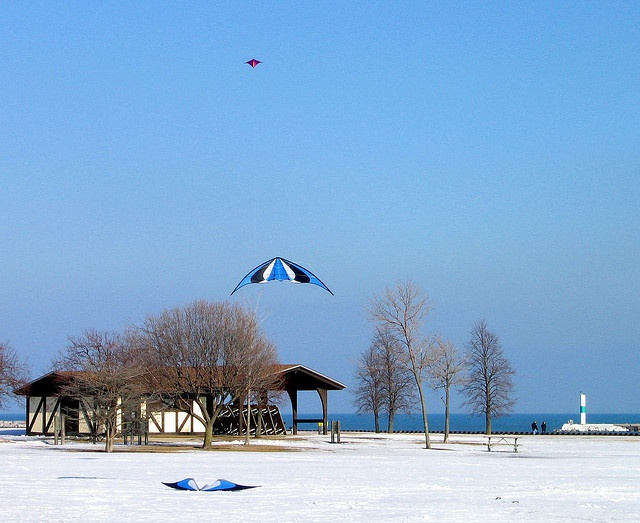Describe the objects in this image and their specific colors. I can see kite in lightblue, black, and navy tones, kite in lightblue, lavender, black, gray, and blue tones, bench in lightblue, black, navy, and teal tones, bench in lightblue, lightgray, darkgray, and gray tones, and people in lightblue, black, navy, teal, and blue tones in this image. 